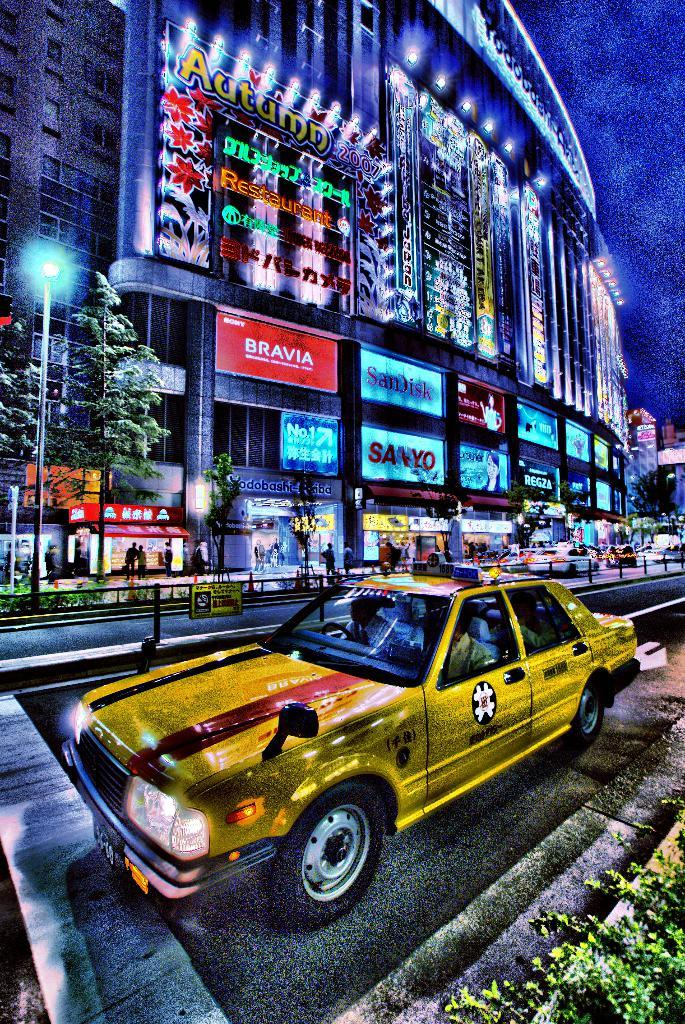<image>
Give a short and clear explanation of the subsequent image. A painting of a yellow taxi cab with a logo for bravia visible on the background. 